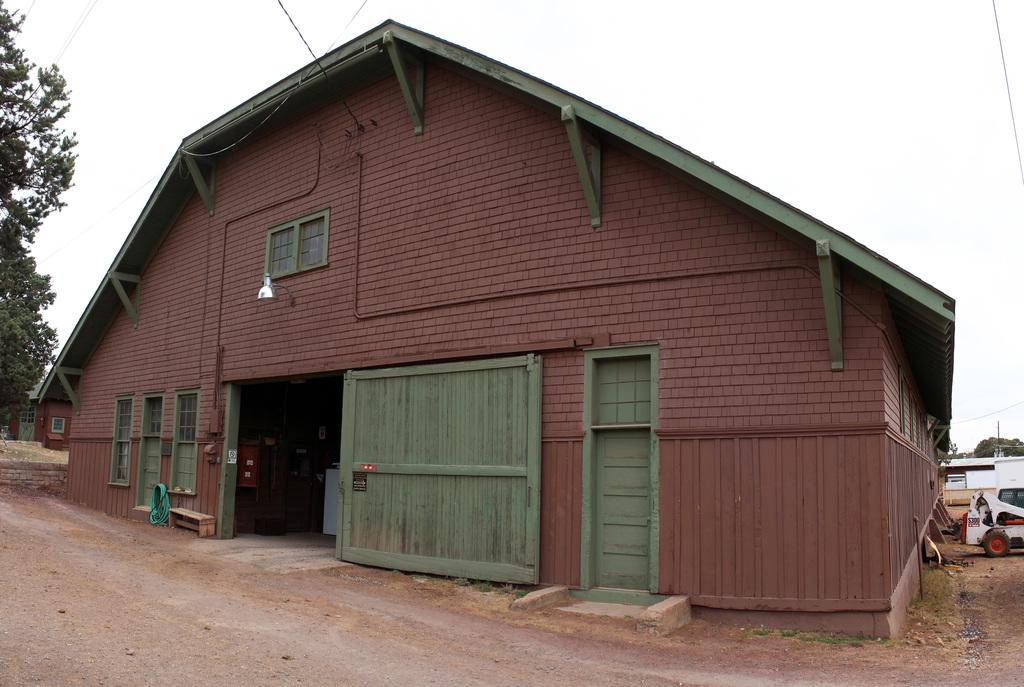What type of structures can be seen in the image? There are houses in the image. What type of surface is visible in the image? There is ground visible in the image. What type of seating is present in the image? There is a bench in the image. What type of transportation is visible in the image? There is a vehicle in the image. What type of vegetation is present in the image? There are trees in the image. What type of illumination is present in the image? There is a light in the image. What type of natural element is visible in the image? The sky is visible in the image. What type of worm can be seen crawling on the vehicle in the image? There is no worm present in the image; only houses, ground, a bench, a vehicle, trees, a light, and the sky are visible. 